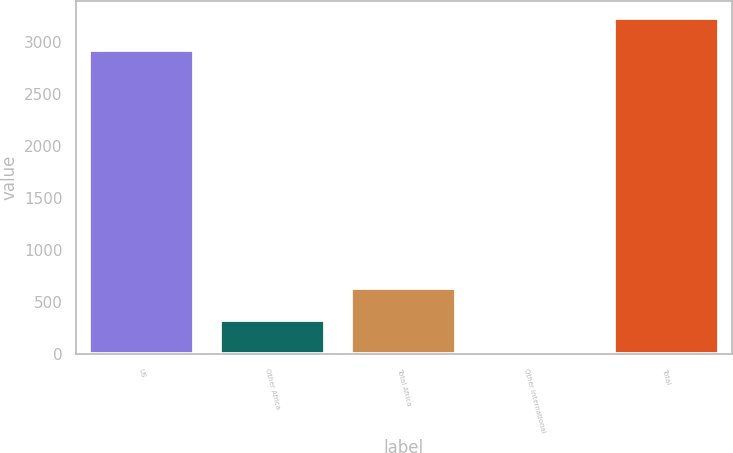Convert chart to OTSL. <chart><loc_0><loc_0><loc_500><loc_500><bar_chart><fcel>US<fcel>Other Africa<fcel>Total Africa<fcel>Other International<fcel>Total<nl><fcel>2919<fcel>329.4<fcel>638.8<fcel>20<fcel>3228.4<nl></chart> 